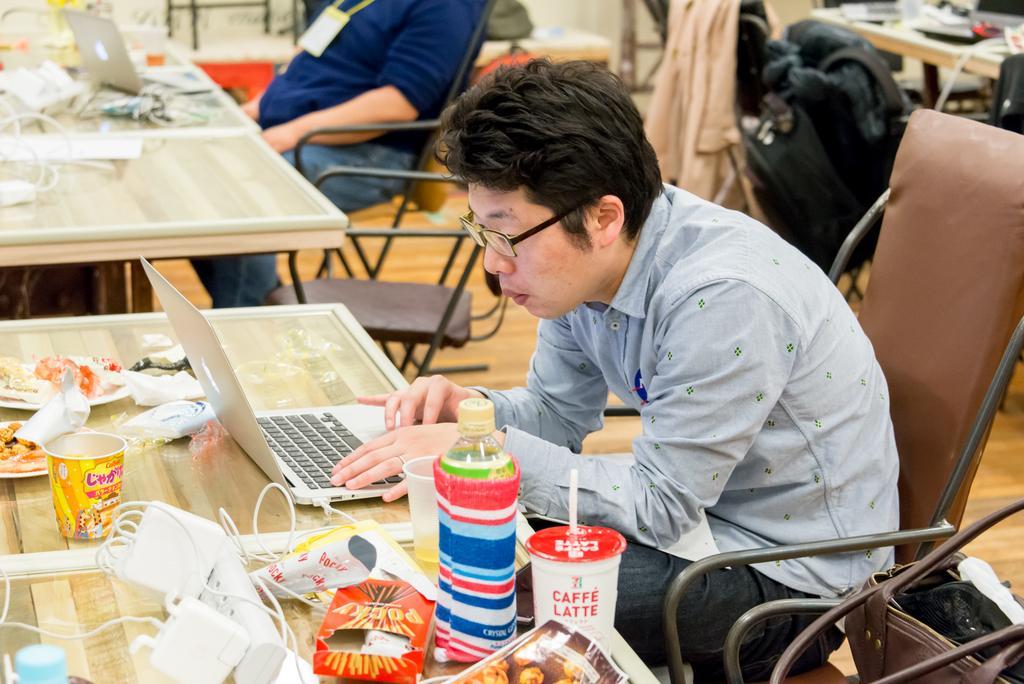Please provide a concise description of this image. In this image I can see two persons sitting in-front of the table. On the table there is a laptop,cups,plates and the bottles. 